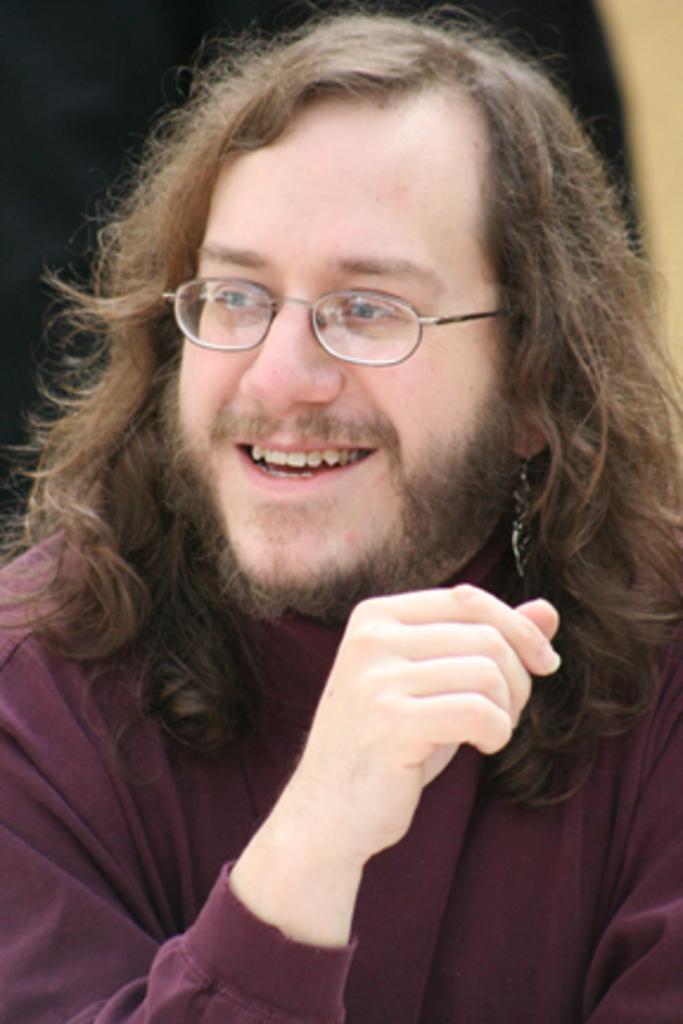Could you give a brief overview of what you see in this image? In this picture there is a man in the center of the image and the background area of the image is black in color. 